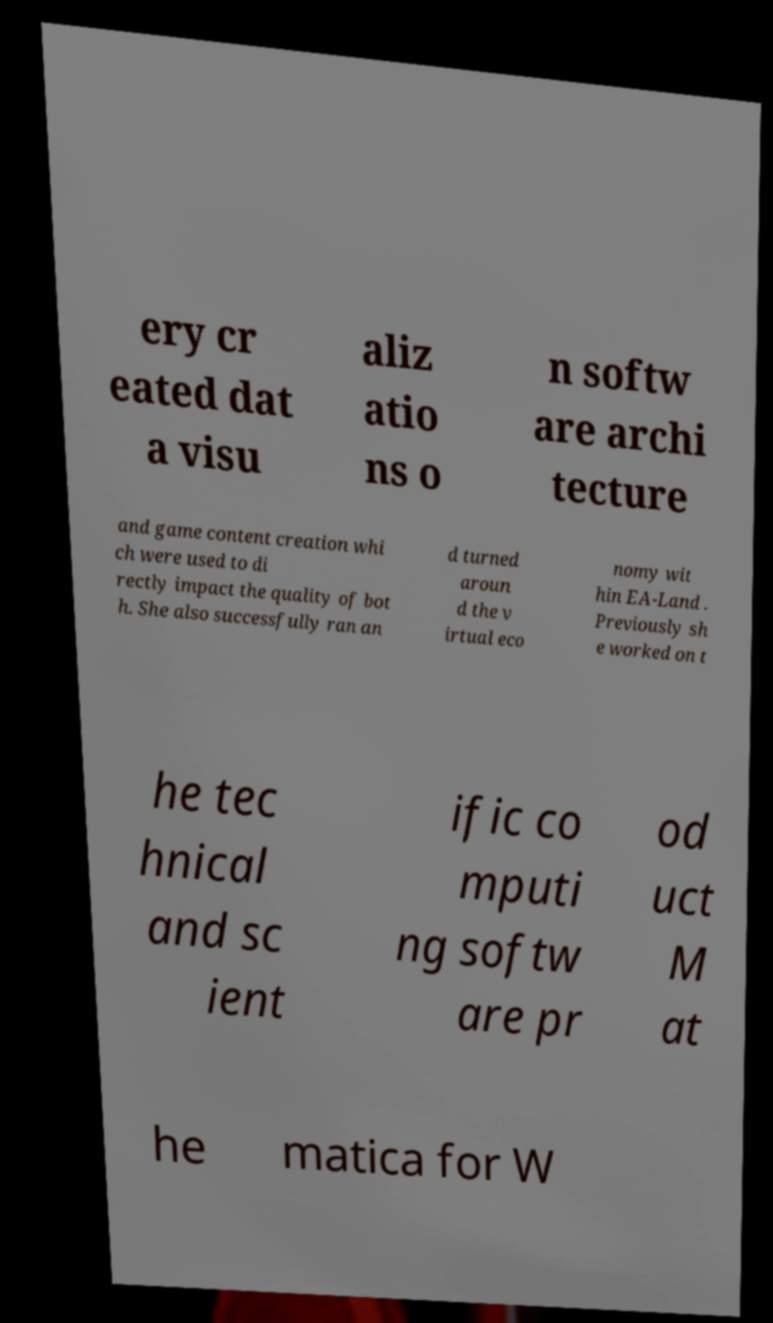I need the written content from this picture converted into text. Can you do that? ery cr eated dat a visu aliz atio ns o n softw are archi tecture and game content creation whi ch were used to di rectly impact the quality of bot h. She also successfully ran an d turned aroun d the v irtual eco nomy wit hin EA-Land . Previously sh e worked on t he tec hnical and sc ient ific co mputi ng softw are pr od uct M at he matica for W 